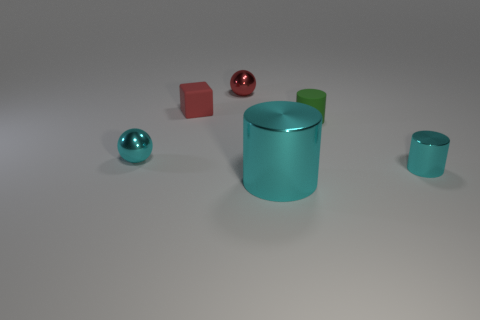Add 4 small red objects. How many objects exist? 10 Subtract all cyan metal cylinders. How many cylinders are left? 1 Subtract all red cubes. How many cyan cylinders are left? 2 Subtract all cubes. How many objects are left? 5 Subtract all rubber cylinders. Subtract all red cubes. How many objects are left? 4 Add 4 red rubber things. How many red rubber things are left? 5 Add 2 tiny objects. How many tiny objects exist? 7 Subtract 1 red spheres. How many objects are left? 5 Subtract all yellow spheres. Subtract all gray cylinders. How many spheres are left? 2 